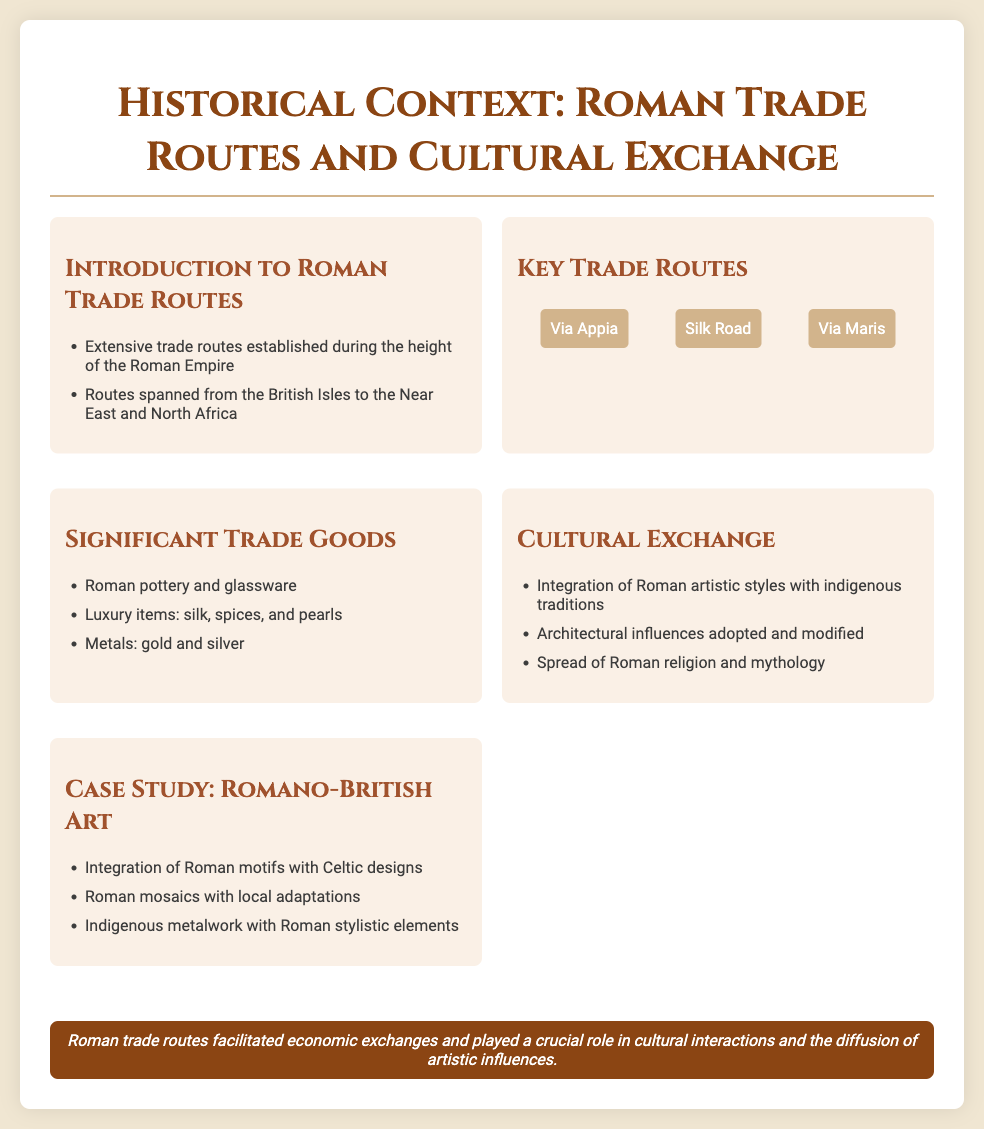what are the key trade routes mentioned? The document lists the three key trade routes associated with Roman trade, which are Via Appia, Silk Road, and Via Maris.
Answer: Via Appia, Silk Road, Via Maris what luxury items were traded? The document specifies that luxury items traded included silk, spices, and pearls.
Answer: silk, spices, and pearls how did Roman trade routes influence indigenous art? The document states that there was an integration of Roman artistic styles with indigenous traditions, revealing the impact on indigenous art practices.
Answer: integration of Roman artistic styles with indigenous traditions which case study is highlighted regarding Roman influence? The document highlights Romano-British art as a case study illustrating Roman influence on indigenous styles through motifs and designs.
Answer: Romano-British art what significant metals were mentioned as trade goods? The document refers to gold and silver as significant traded metals.
Answer: gold and silver how did Roman architecture influence local styles? The document notes that architectural influences were adopted and modified, indicating a blend of styles.
Answer: adopted and modified what role did Roman religion play in cultural exchange? The document mentions the spread of Roman religion and mythology as part of cultural interactions.
Answer: spread of Roman religion and mythology what is the conclusion regarding trade routes? The conclusion emphasizes the role of Roman trade routes in economic exchanges and cultural interactions, highlighting their importance.
Answer: crucial role in cultural interactions and the diffusion of artistic influences 